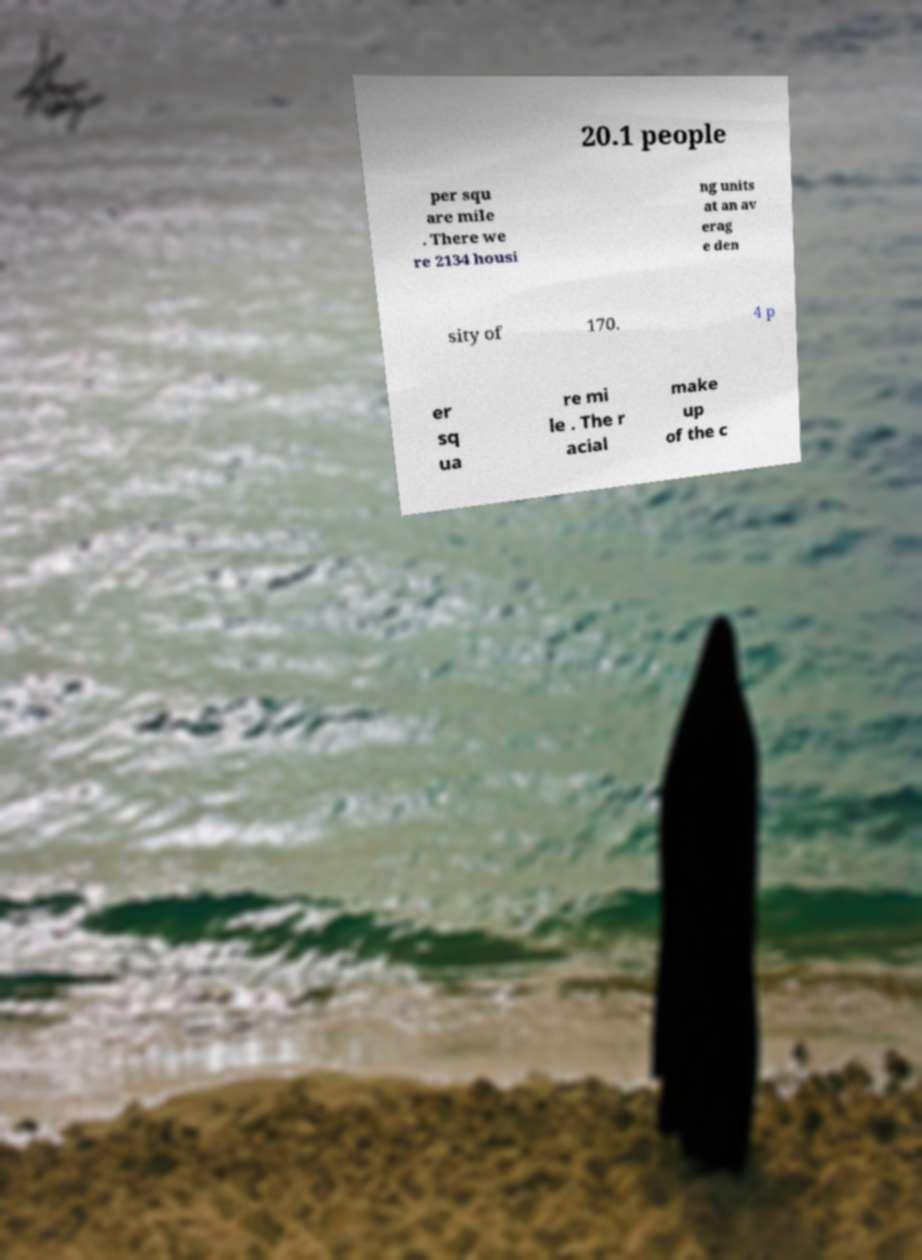Can you read and provide the text displayed in the image?This photo seems to have some interesting text. Can you extract and type it out for me? 20.1 people per squ are mile . There we re 2134 housi ng units at an av erag e den sity of 170. 4 p er sq ua re mi le . The r acial make up of the c 